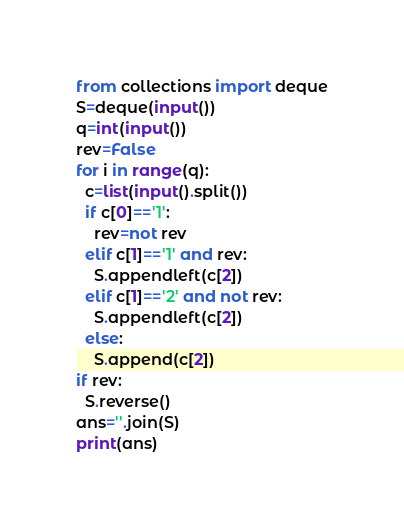Convert code to text. <code><loc_0><loc_0><loc_500><loc_500><_Python_>from collections import deque
S=deque(input())
q=int(input())
rev=False
for i in range(q):
  c=list(input().split())
  if c[0]=='1':
    rev=not rev
  elif c[1]=='1' and rev:
    S.appendleft(c[2])
  elif c[1]=='2' and not rev:
    S.appendleft(c[2])
  else:
    S.append(c[2])
if rev:
  S.reverse()
ans=''.join(S)
print(ans)</code> 